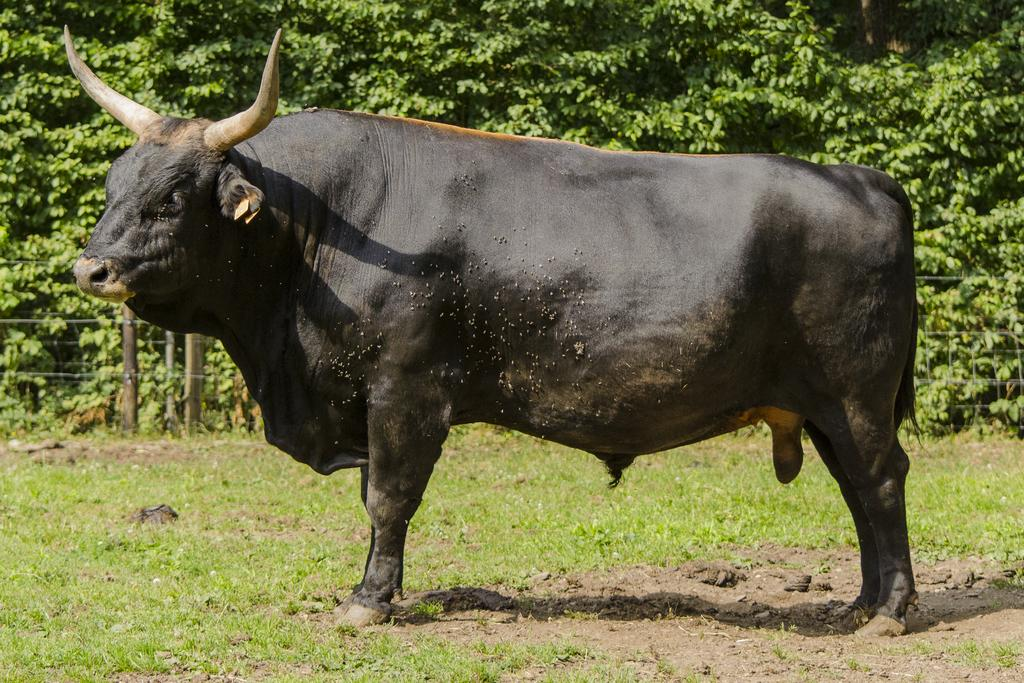What type of ground is visible in the image? There is grass ground in the image. What animal is standing in the front of the image? A black color bull is standing in the front of the image. What can be seen in the background of the image? There are trees and poles visible in the background of the image. Are there any wires present in the image? Yes, there are wires in the background of the image. How does the zebra react to the rainstorm in the image? There is no zebra or rainstorm present in the image. What month is it in the image? The month cannot be determined from the image, as there is no information about the time of year. 